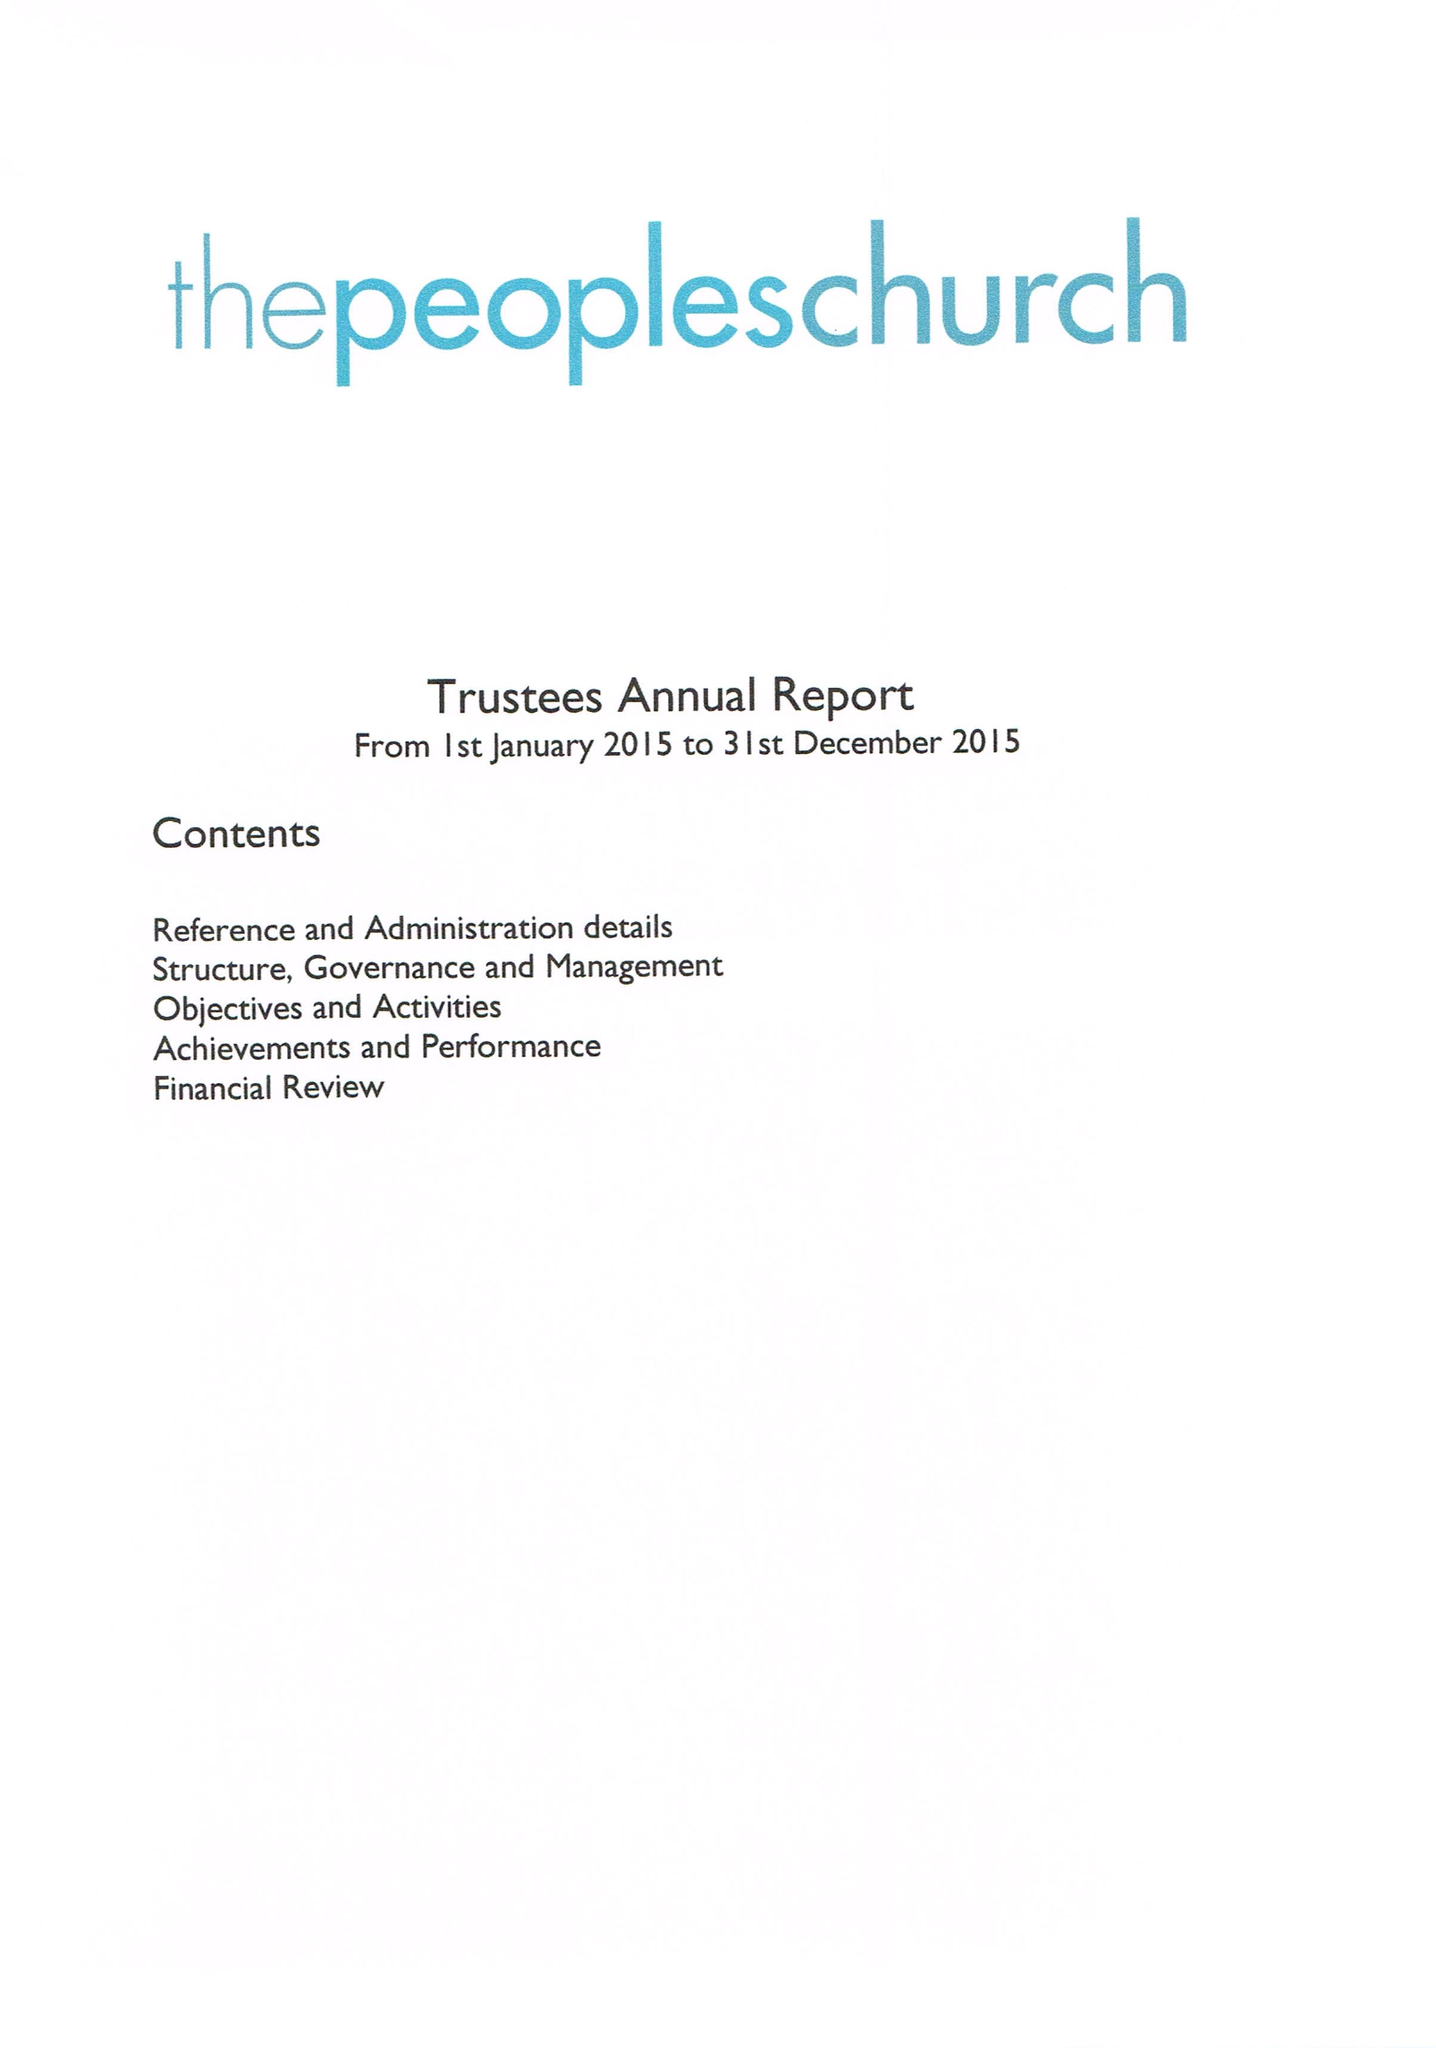What is the value for the charity_name?
Answer the question using a single word or phrase. The Peoples Church (Banbury) 